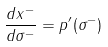<formula> <loc_0><loc_0><loc_500><loc_500>\frac { d x ^ { - } } { d \sigma ^ { - } } = p ^ { \prime } ( \sigma ^ { - } )</formula> 